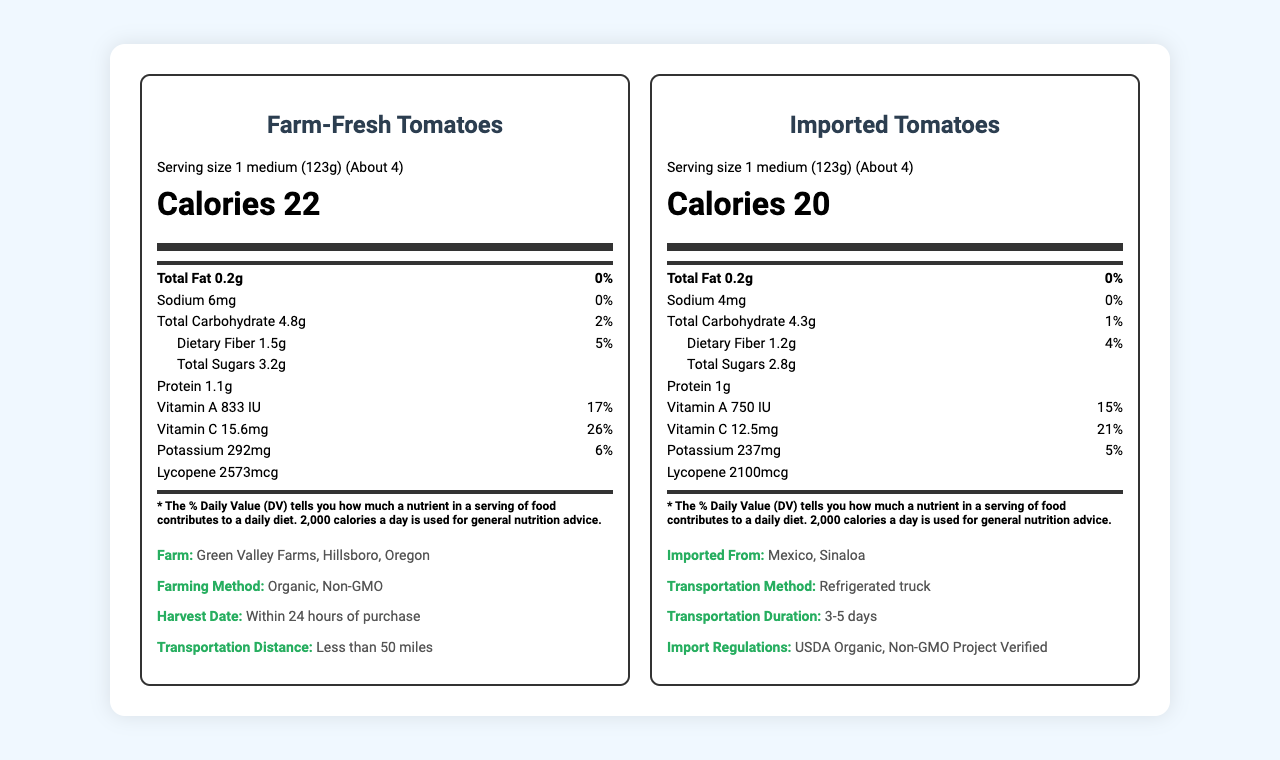what is the serving size of the local produce? The serving size for Farm-Fresh Tomatoes is specified as "1 medium (123g)" under the serving information.
Answer: 1 medium (123g) what is the daily value percentage of vitamin C in imported tomatoes? The label for Imported Tomatoes shows "Vitamin C 12.5mg" with a daily value percentage of "21%".
Answer: 21% how much protein is there in the local tomatoes? The nutrient information for Farm-Fresh Tomatoes lists "Protein 1.1g".
Answer: 1.1g what is the transportation distance for the local produce? The additional information section for Farm-Fresh Tomatoes mentions a transportation distance of "Less than 50 miles".
Answer: Less than 50 miles compare the potassium content between local and imported tomatoes. The nutrient information shows that Farm-Fresh Tomatoes contain 292mg of potassium, while Imported Tomatoes have 237mg.
Answer: Local: 292mg, Imported: 237mg which produce has a higher dietary fiber content? A. Local Tomatoes B. Imported Tomatoes Local Tomatoes have 1.5g of dietary fiber while Imported Tomatoes have 1.2g.
Answer: A which produce has more total sugars? 1. Local Tomatoes 2. Imported Tomatoes Local Tomatoes have 3.2g of total sugars, whereas Imported Tomatoes contain 2.8g.
Answer: 1 is the daily value of total fat different between the local and imported tomatoes? The total fat content for both Farm-Fresh and Imported Tomatoes is listed as 0% daily value.
Answer: No are the local tomatoes GMO? The additional information states that local tomatoes from Green Valley Farms are "Organic, Non-GMO".
Answer: No summarize the main nutritional differences between local and imported tomatoes. Based on the provided nutrient profiles and additional information, local tomatoes have a slightly higher nutrient content in several categories and benefit from being fresher due to shorter transportation, as well as being grown under organic and non-GMO methods.
Answer: Local tomatoes have higher calories, carbohydrates, dietary fiber, total sugars, vitamin A, vitamin C, potassium, and lycopene compared to imported tomatoes, which have slightly lower values for almost all nutrients. Local produce also benefits from being organic and non-GMO with a shorter transport distance. what was the harvest date of the imported tomatoes? The document provides the harvest date for local tomatoes but does not mention the harvest date for imported tomatoes.
Answer: Cannot be determined 